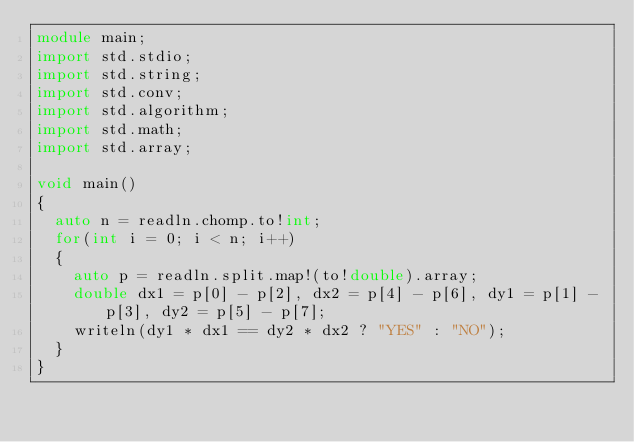Convert code to text. <code><loc_0><loc_0><loc_500><loc_500><_D_>module main;
import std.stdio;
import std.string;
import std.conv;
import std.algorithm;
import std.math;
import std.array;

void main()
{
  auto n = readln.chomp.to!int;
  for(int i = 0; i < n; i++)
  {
    auto p = readln.split.map!(to!double).array;
    double dx1 = p[0] - p[2], dx2 = p[4] - p[6], dy1 = p[1] - p[3], dy2 = p[5] - p[7];
    writeln(dy1 * dx1 == dy2 * dx2 ? "YES" : "NO"); 
  }
}</code> 